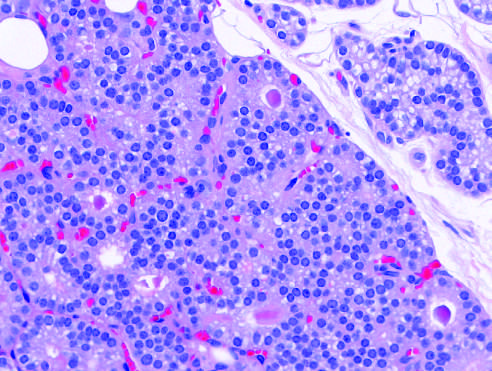does the granulomatous response show minimal variation in nuclear size and occasional follicle formation?
Answer the question using a single word or phrase. No 